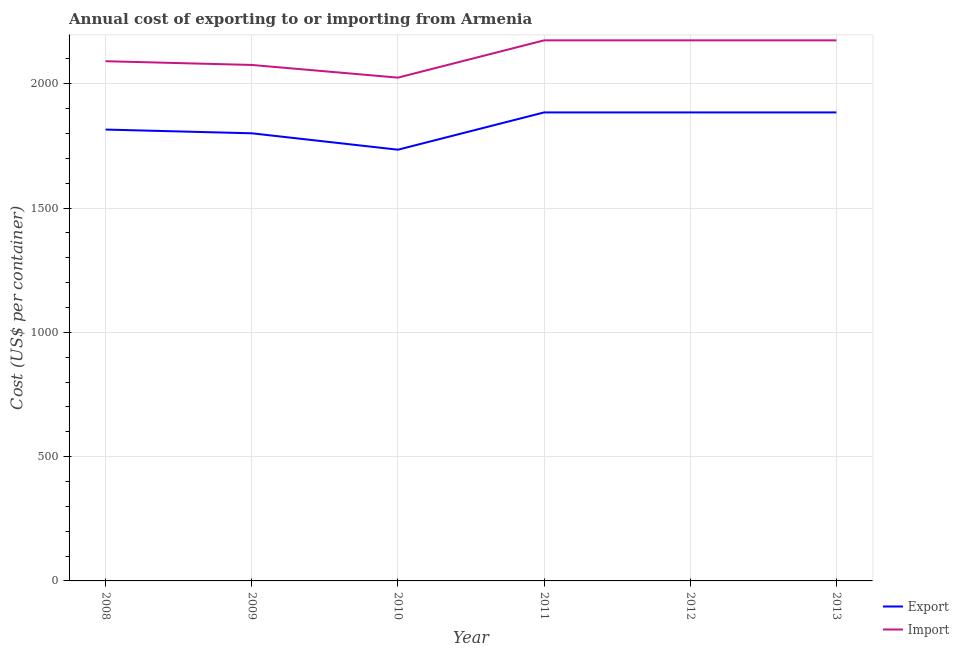How many different coloured lines are there?
Offer a very short reply. 2. What is the export cost in 2008?
Your response must be concise. 1816. Across all years, what is the maximum import cost?
Make the answer very short. 2175. Across all years, what is the minimum import cost?
Your answer should be very brief. 2025. What is the total export cost in the graph?
Provide a succinct answer. 1.10e+04. What is the difference between the import cost in 2010 and the export cost in 2011?
Your answer should be compact. 140. What is the average export cost per year?
Ensure brevity in your answer.  1834.5. In the year 2009, what is the difference between the export cost and import cost?
Ensure brevity in your answer.  -275. What is the ratio of the import cost in 2009 to that in 2013?
Give a very brief answer. 0.95. Is the difference between the export cost in 2008 and 2009 greater than the difference between the import cost in 2008 and 2009?
Give a very brief answer. No. What is the difference between the highest and the lowest export cost?
Your answer should be very brief. 150. Is the sum of the export cost in 2008 and 2011 greater than the maximum import cost across all years?
Ensure brevity in your answer.  Yes. How many lines are there?
Your answer should be very brief. 2. What is the difference between two consecutive major ticks on the Y-axis?
Your answer should be very brief. 500. Does the graph contain any zero values?
Offer a very short reply. No. How many legend labels are there?
Give a very brief answer. 2. How are the legend labels stacked?
Give a very brief answer. Vertical. What is the title of the graph?
Offer a very short reply. Annual cost of exporting to or importing from Armenia. What is the label or title of the Y-axis?
Your response must be concise. Cost (US$ per container). What is the Cost (US$ per container) in Export in 2008?
Make the answer very short. 1816. What is the Cost (US$ per container) of Import in 2008?
Offer a very short reply. 2091. What is the Cost (US$ per container) in Export in 2009?
Make the answer very short. 1801. What is the Cost (US$ per container) of Import in 2009?
Your response must be concise. 2076. What is the Cost (US$ per container) in Export in 2010?
Make the answer very short. 1735. What is the Cost (US$ per container) in Import in 2010?
Give a very brief answer. 2025. What is the Cost (US$ per container) in Export in 2011?
Keep it short and to the point. 1885. What is the Cost (US$ per container) of Import in 2011?
Your answer should be very brief. 2175. What is the Cost (US$ per container) of Export in 2012?
Ensure brevity in your answer.  1885. What is the Cost (US$ per container) of Import in 2012?
Offer a very short reply. 2175. What is the Cost (US$ per container) of Export in 2013?
Your answer should be compact. 1885. What is the Cost (US$ per container) in Import in 2013?
Your answer should be very brief. 2175. Across all years, what is the maximum Cost (US$ per container) of Export?
Your answer should be compact. 1885. Across all years, what is the maximum Cost (US$ per container) in Import?
Ensure brevity in your answer.  2175. Across all years, what is the minimum Cost (US$ per container) of Export?
Your response must be concise. 1735. Across all years, what is the minimum Cost (US$ per container) in Import?
Ensure brevity in your answer.  2025. What is the total Cost (US$ per container) of Export in the graph?
Provide a succinct answer. 1.10e+04. What is the total Cost (US$ per container) of Import in the graph?
Your answer should be compact. 1.27e+04. What is the difference between the Cost (US$ per container) of Export in 2008 and that in 2010?
Your answer should be very brief. 81. What is the difference between the Cost (US$ per container) of Import in 2008 and that in 2010?
Your answer should be compact. 66. What is the difference between the Cost (US$ per container) of Export in 2008 and that in 2011?
Keep it short and to the point. -69. What is the difference between the Cost (US$ per container) of Import in 2008 and that in 2011?
Give a very brief answer. -84. What is the difference between the Cost (US$ per container) in Export in 2008 and that in 2012?
Provide a succinct answer. -69. What is the difference between the Cost (US$ per container) in Import in 2008 and that in 2012?
Provide a succinct answer. -84. What is the difference between the Cost (US$ per container) of Export in 2008 and that in 2013?
Your response must be concise. -69. What is the difference between the Cost (US$ per container) of Import in 2008 and that in 2013?
Keep it short and to the point. -84. What is the difference between the Cost (US$ per container) of Export in 2009 and that in 2011?
Ensure brevity in your answer.  -84. What is the difference between the Cost (US$ per container) in Import in 2009 and that in 2011?
Give a very brief answer. -99. What is the difference between the Cost (US$ per container) in Export in 2009 and that in 2012?
Give a very brief answer. -84. What is the difference between the Cost (US$ per container) in Import in 2009 and that in 2012?
Your response must be concise. -99. What is the difference between the Cost (US$ per container) of Export in 2009 and that in 2013?
Keep it short and to the point. -84. What is the difference between the Cost (US$ per container) in Import in 2009 and that in 2013?
Provide a short and direct response. -99. What is the difference between the Cost (US$ per container) of Export in 2010 and that in 2011?
Provide a short and direct response. -150. What is the difference between the Cost (US$ per container) of Import in 2010 and that in 2011?
Keep it short and to the point. -150. What is the difference between the Cost (US$ per container) in Export in 2010 and that in 2012?
Your answer should be compact. -150. What is the difference between the Cost (US$ per container) in Import in 2010 and that in 2012?
Ensure brevity in your answer.  -150. What is the difference between the Cost (US$ per container) in Export in 2010 and that in 2013?
Keep it short and to the point. -150. What is the difference between the Cost (US$ per container) in Import in 2010 and that in 2013?
Keep it short and to the point. -150. What is the difference between the Cost (US$ per container) of Export in 2011 and that in 2012?
Your response must be concise. 0. What is the difference between the Cost (US$ per container) of Export in 2012 and that in 2013?
Your answer should be compact. 0. What is the difference between the Cost (US$ per container) in Import in 2012 and that in 2013?
Provide a succinct answer. 0. What is the difference between the Cost (US$ per container) of Export in 2008 and the Cost (US$ per container) of Import in 2009?
Provide a short and direct response. -260. What is the difference between the Cost (US$ per container) of Export in 2008 and the Cost (US$ per container) of Import in 2010?
Provide a succinct answer. -209. What is the difference between the Cost (US$ per container) in Export in 2008 and the Cost (US$ per container) in Import in 2011?
Provide a short and direct response. -359. What is the difference between the Cost (US$ per container) in Export in 2008 and the Cost (US$ per container) in Import in 2012?
Your answer should be very brief. -359. What is the difference between the Cost (US$ per container) in Export in 2008 and the Cost (US$ per container) in Import in 2013?
Keep it short and to the point. -359. What is the difference between the Cost (US$ per container) in Export in 2009 and the Cost (US$ per container) in Import in 2010?
Give a very brief answer. -224. What is the difference between the Cost (US$ per container) in Export in 2009 and the Cost (US$ per container) in Import in 2011?
Your answer should be very brief. -374. What is the difference between the Cost (US$ per container) of Export in 2009 and the Cost (US$ per container) of Import in 2012?
Provide a short and direct response. -374. What is the difference between the Cost (US$ per container) in Export in 2009 and the Cost (US$ per container) in Import in 2013?
Offer a terse response. -374. What is the difference between the Cost (US$ per container) in Export in 2010 and the Cost (US$ per container) in Import in 2011?
Your answer should be compact. -440. What is the difference between the Cost (US$ per container) in Export in 2010 and the Cost (US$ per container) in Import in 2012?
Offer a terse response. -440. What is the difference between the Cost (US$ per container) of Export in 2010 and the Cost (US$ per container) of Import in 2013?
Offer a terse response. -440. What is the difference between the Cost (US$ per container) of Export in 2011 and the Cost (US$ per container) of Import in 2012?
Provide a succinct answer. -290. What is the difference between the Cost (US$ per container) in Export in 2011 and the Cost (US$ per container) in Import in 2013?
Keep it short and to the point. -290. What is the difference between the Cost (US$ per container) in Export in 2012 and the Cost (US$ per container) in Import in 2013?
Your answer should be very brief. -290. What is the average Cost (US$ per container) in Export per year?
Make the answer very short. 1834.5. What is the average Cost (US$ per container) of Import per year?
Offer a terse response. 2119.5. In the year 2008, what is the difference between the Cost (US$ per container) in Export and Cost (US$ per container) in Import?
Make the answer very short. -275. In the year 2009, what is the difference between the Cost (US$ per container) in Export and Cost (US$ per container) in Import?
Your answer should be very brief. -275. In the year 2010, what is the difference between the Cost (US$ per container) in Export and Cost (US$ per container) in Import?
Your answer should be compact. -290. In the year 2011, what is the difference between the Cost (US$ per container) of Export and Cost (US$ per container) of Import?
Your response must be concise. -290. In the year 2012, what is the difference between the Cost (US$ per container) of Export and Cost (US$ per container) of Import?
Offer a terse response. -290. In the year 2013, what is the difference between the Cost (US$ per container) of Export and Cost (US$ per container) of Import?
Your answer should be very brief. -290. What is the ratio of the Cost (US$ per container) in Export in 2008 to that in 2009?
Your answer should be compact. 1.01. What is the ratio of the Cost (US$ per container) in Export in 2008 to that in 2010?
Your answer should be very brief. 1.05. What is the ratio of the Cost (US$ per container) of Import in 2008 to that in 2010?
Offer a terse response. 1.03. What is the ratio of the Cost (US$ per container) in Export in 2008 to that in 2011?
Offer a very short reply. 0.96. What is the ratio of the Cost (US$ per container) of Import in 2008 to that in 2011?
Ensure brevity in your answer.  0.96. What is the ratio of the Cost (US$ per container) of Export in 2008 to that in 2012?
Give a very brief answer. 0.96. What is the ratio of the Cost (US$ per container) in Import in 2008 to that in 2012?
Ensure brevity in your answer.  0.96. What is the ratio of the Cost (US$ per container) in Export in 2008 to that in 2013?
Your answer should be very brief. 0.96. What is the ratio of the Cost (US$ per container) of Import in 2008 to that in 2013?
Provide a short and direct response. 0.96. What is the ratio of the Cost (US$ per container) of Export in 2009 to that in 2010?
Your response must be concise. 1.04. What is the ratio of the Cost (US$ per container) of Import in 2009 to that in 2010?
Your response must be concise. 1.03. What is the ratio of the Cost (US$ per container) in Export in 2009 to that in 2011?
Keep it short and to the point. 0.96. What is the ratio of the Cost (US$ per container) of Import in 2009 to that in 2011?
Ensure brevity in your answer.  0.95. What is the ratio of the Cost (US$ per container) of Export in 2009 to that in 2012?
Ensure brevity in your answer.  0.96. What is the ratio of the Cost (US$ per container) in Import in 2009 to that in 2012?
Give a very brief answer. 0.95. What is the ratio of the Cost (US$ per container) in Export in 2009 to that in 2013?
Make the answer very short. 0.96. What is the ratio of the Cost (US$ per container) of Import in 2009 to that in 2013?
Your answer should be compact. 0.95. What is the ratio of the Cost (US$ per container) of Export in 2010 to that in 2011?
Provide a succinct answer. 0.92. What is the ratio of the Cost (US$ per container) of Import in 2010 to that in 2011?
Keep it short and to the point. 0.93. What is the ratio of the Cost (US$ per container) of Export in 2010 to that in 2012?
Your answer should be compact. 0.92. What is the ratio of the Cost (US$ per container) of Import in 2010 to that in 2012?
Your answer should be compact. 0.93. What is the ratio of the Cost (US$ per container) of Export in 2010 to that in 2013?
Ensure brevity in your answer.  0.92. What is the ratio of the Cost (US$ per container) of Import in 2010 to that in 2013?
Ensure brevity in your answer.  0.93. What is the ratio of the Cost (US$ per container) in Export in 2011 to that in 2012?
Offer a very short reply. 1. What is the ratio of the Cost (US$ per container) of Export in 2011 to that in 2013?
Your response must be concise. 1. What is the ratio of the Cost (US$ per container) of Export in 2012 to that in 2013?
Keep it short and to the point. 1. What is the difference between the highest and the second highest Cost (US$ per container) of Import?
Keep it short and to the point. 0. What is the difference between the highest and the lowest Cost (US$ per container) in Export?
Your answer should be compact. 150. What is the difference between the highest and the lowest Cost (US$ per container) in Import?
Keep it short and to the point. 150. 